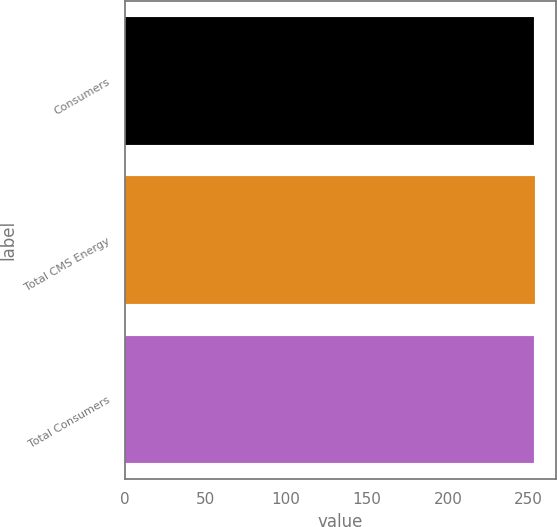Convert chart. <chart><loc_0><loc_0><loc_500><loc_500><bar_chart><fcel>Consumers<fcel>Total CMS Energy<fcel>Total Consumers<nl><fcel>253<fcel>254<fcel>253.1<nl></chart> 